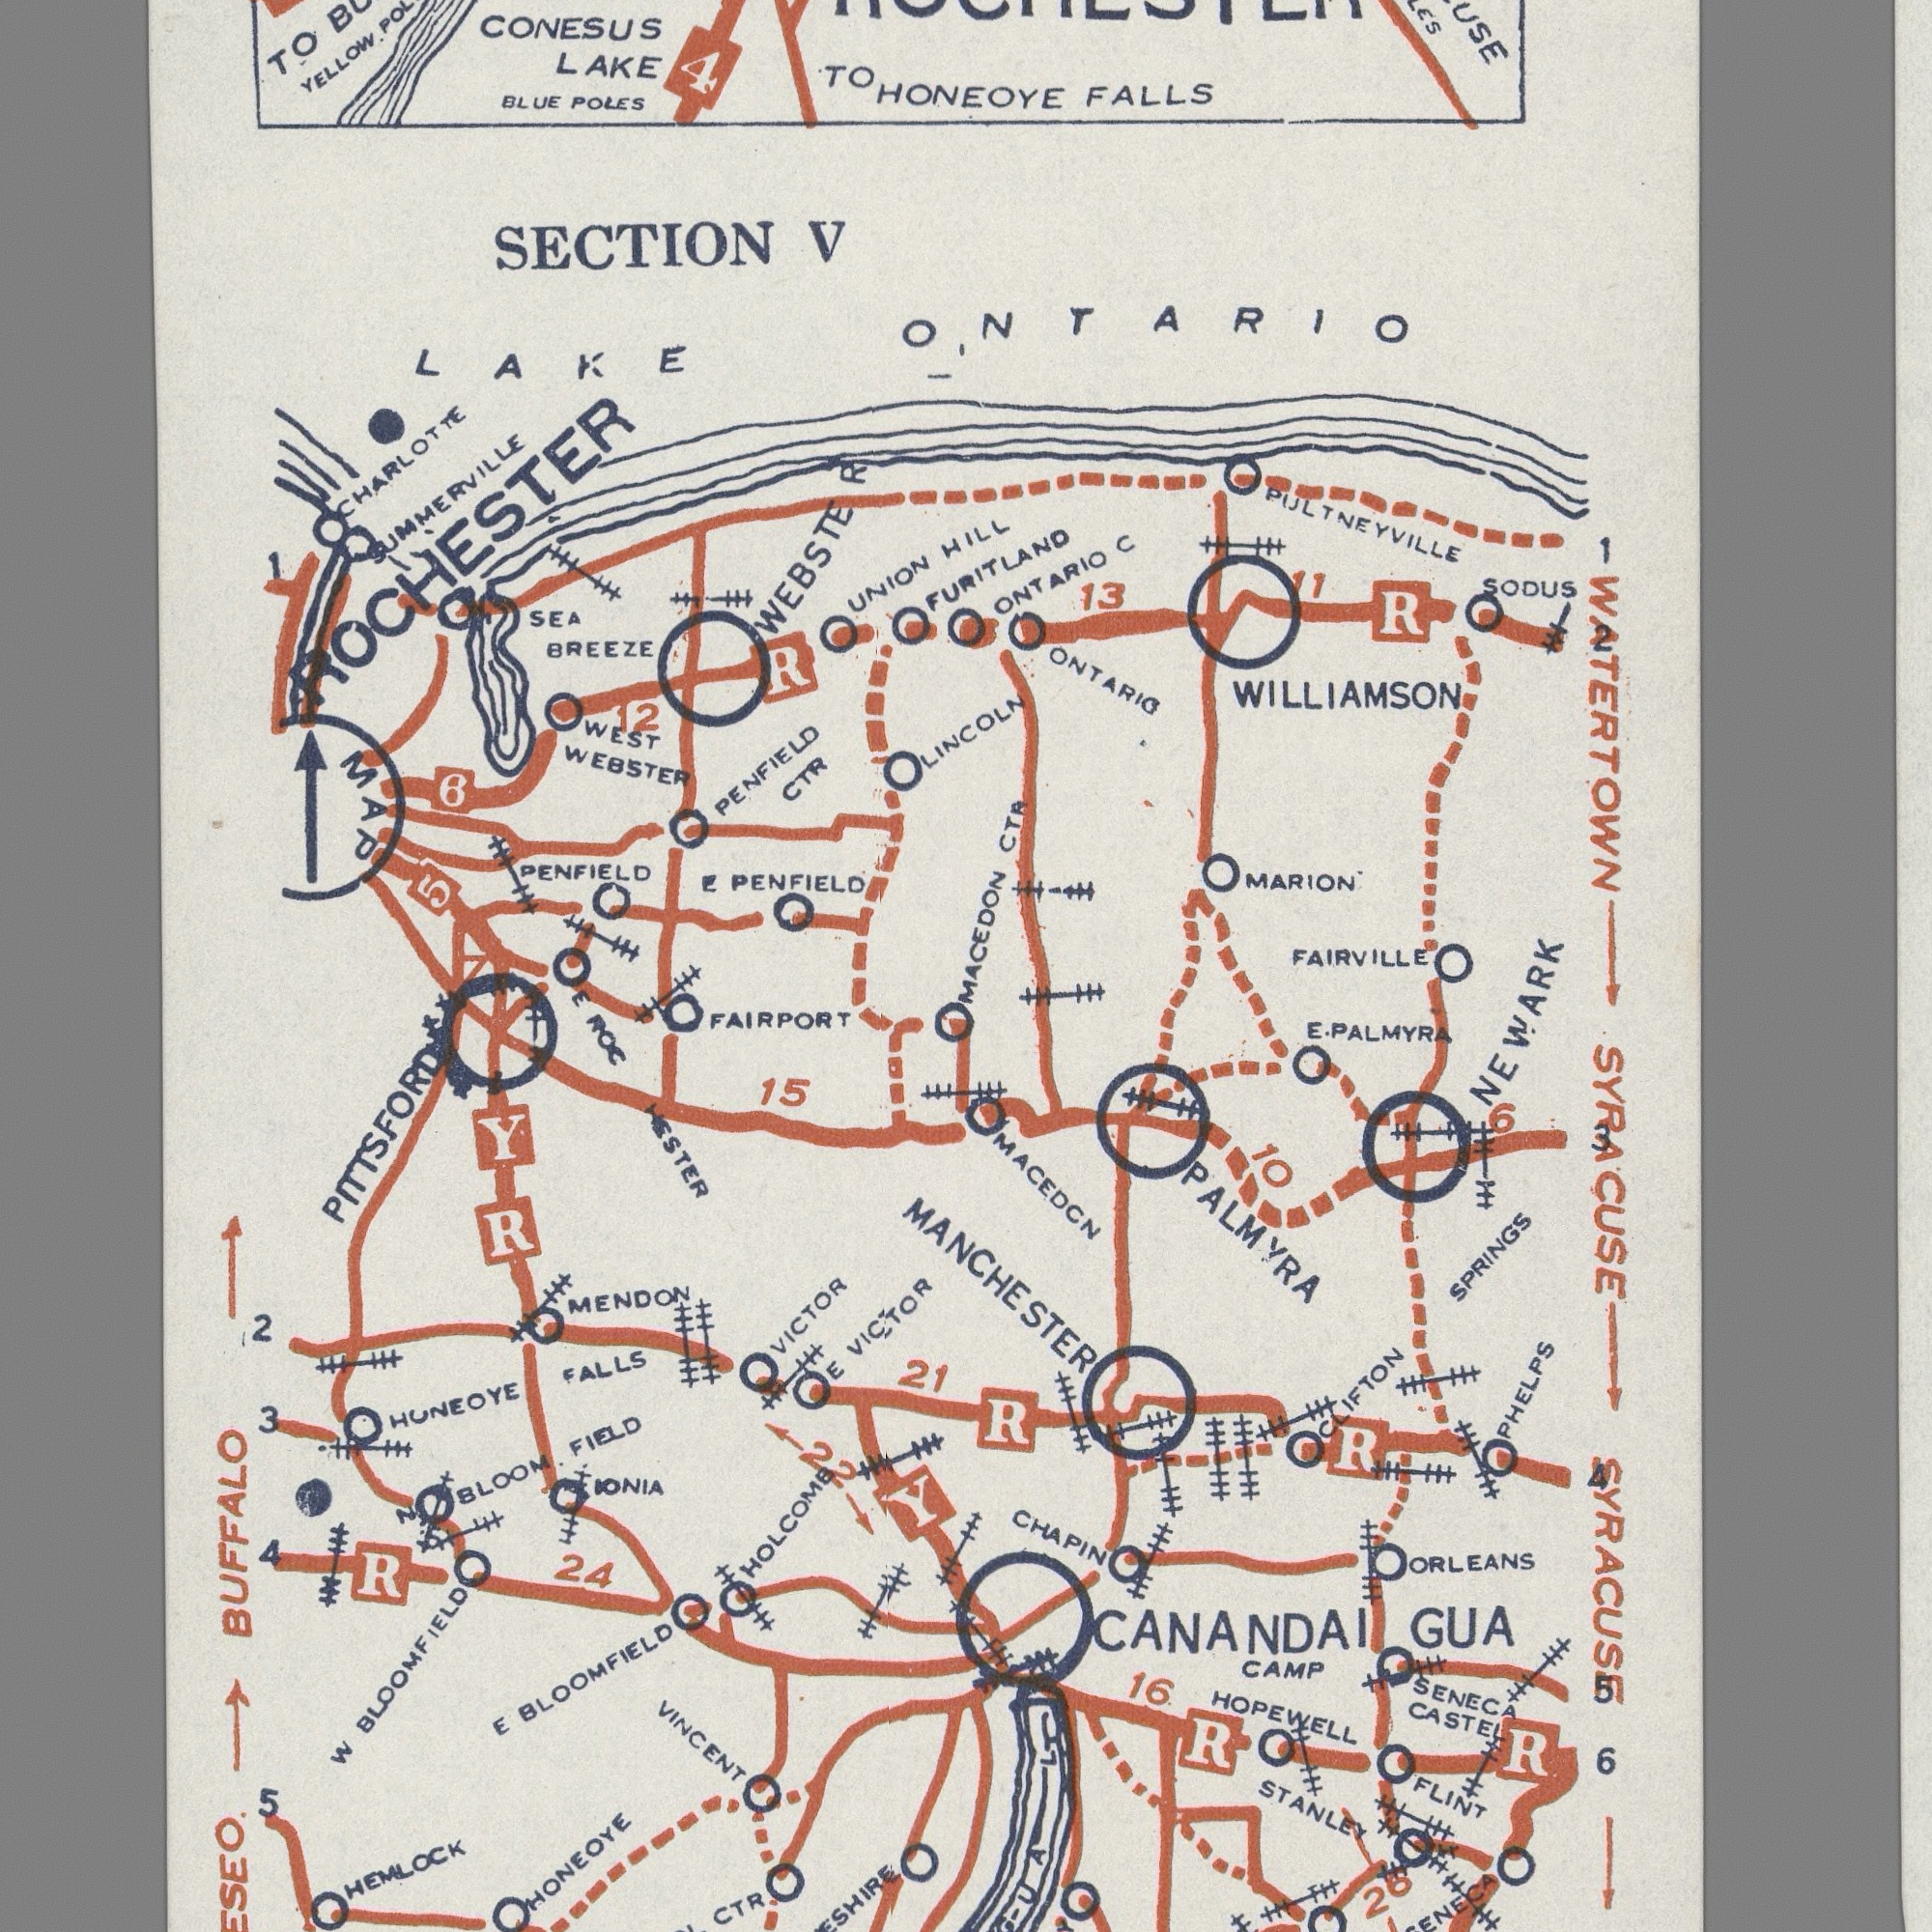What text can you see in the top-right section? HILL FALLS WILLIAMSON MACEDON ONTARIO MARION CTR 13 FAIRVILLE HONEOYE ONTARIO PULTNEYVILLE SODUS ONTARIO FURITLAND WATERTOWN LINCOLN R 11 1 2 C What text appears in the top-left area of the image? SECTION CONESUS CHARLOTTE WEBSTER POLES SEA UNION WEBSTE PENFIELD WEST TO V BLUE 1 TO CTR PENFIELD 6 PENFIELD YELLOW. SUMMERVILLE R LAKE LAKE MAP ROCHESTER BREEZE 4 5 12 R E What text can you see in the bottom-right section? 21 HOPEWELL SYRACUSE NEWARK STANLEY MANCHESTER GUA CAMP SYRACUSE CHAPIN 16 ORLEANS PALMYRA FLINT 10 PALMYRA SENECA PHELPS MACEDCN SPRINGS CASTEL E. CLIFTON 6 R 6 CANANDAI R R 26 3 4 5 R A L What text is shown in the bottom-left quadrant? BUFFALO PITTSFORD BLOOMFIELD HUNEOYE VICTOR 15 FIELD FALLS IONIA MENDON 24 HEMLOCK ROC W VINCENT VICTOR 2 5 CTR HESTER BLOOMFIELD 3 HOLCOMB E HONEOYE BLOOM. 4 R E FAIRPORT R Y Y 22 E 